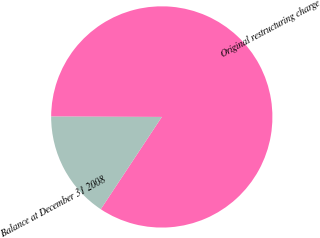Convert chart to OTSL. <chart><loc_0><loc_0><loc_500><loc_500><pie_chart><fcel>Original restructuring charge<fcel>Balance at December 31 2008<nl><fcel>84.25%<fcel>15.75%<nl></chart> 